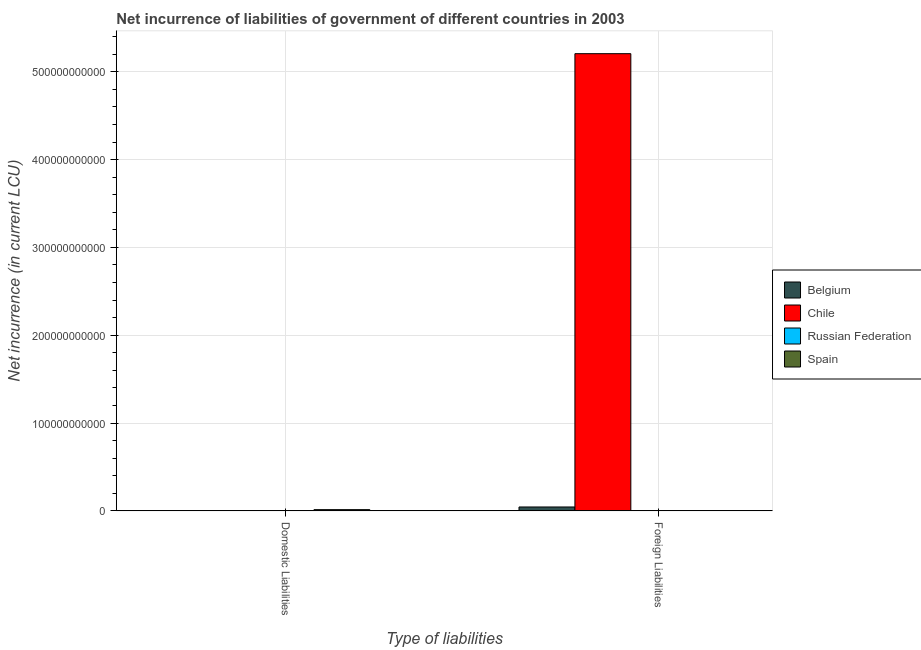How many different coloured bars are there?
Ensure brevity in your answer.  3. Are the number of bars on each tick of the X-axis equal?
Provide a succinct answer. No. How many bars are there on the 2nd tick from the left?
Give a very brief answer. 2. How many bars are there on the 2nd tick from the right?
Provide a short and direct response. 1. What is the label of the 1st group of bars from the left?
Keep it short and to the point. Domestic Liabilities. What is the net incurrence of foreign liabilities in Chile?
Make the answer very short. 5.21e+11. Across all countries, what is the maximum net incurrence of domestic liabilities?
Offer a terse response. 1.42e+09. What is the total net incurrence of foreign liabilities in the graph?
Your answer should be very brief. 5.25e+11. What is the difference between the net incurrence of foreign liabilities in Belgium and that in Chile?
Ensure brevity in your answer.  -5.16e+11. What is the difference between the net incurrence of foreign liabilities in Chile and the net incurrence of domestic liabilities in Belgium?
Your answer should be compact. 5.21e+11. What is the average net incurrence of domestic liabilities per country?
Your answer should be compact. 3.55e+08. In how many countries, is the net incurrence of domestic liabilities greater than the average net incurrence of domestic liabilities taken over all countries?
Offer a very short reply. 1. What is the difference between two consecutive major ticks on the Y-axis?
Give a very brief answer. 1.00e+11. Does the graph contain any zero values?
Offer a very short reply. Yes. What is the title of the graph?
Offer a terse response. Net incurrence of liabilities of government of different countries in 2003. Does "Mongolia" appear as one of the legend labels in the graph?
Your response must be concise. No. What is the label or title of the X-axis?
Offer a terse response. Type of liabilities. What is the label or title of the Y-axis?
Offer a very short reply. Net incurrence (in current LCU). What is the Net incurrence (in current LCU) in Belgium in Domestic Liabilities?
Your answer should be very brief. 0. What is the Net incurrence (in current LCU) in Spain in Domestic Liabilities?
Your answer should be very brief. 1.42e+09. What is the Net incurrence (in current LCU) of Belgium in Foreign Liabilities?
Keep it short and to the point. 4.45e+09. What is the Net incurrence (in current LCU) in Chile in Foreign Liabilities?
Ensure brevity in your answer.  5.21e+11. What is the Net incurrence (in current LCU) of Spain in Foreign Liabilities?
Offer a terse response. 0. Across all Type of liabilities, what is the maximum Net incurrence (in current LCU) of Belgium?
Offer a terse response. 4.45e+09. Across all Type of liabilities, what is the maximum Net incurrence (in current LCU) of Chile?
Keep it short and to the point. 5.21e+11. Across all Type of liabilities, what is the maximum Net incurrence (in current LCU) in Spain?
Make the answer very short. 1.42e+09. Across all Type of liabilities, what is the minimum Net incurrence (in current LCU) of Belgium?
Your answer should be compact. 0. Across all Type of liabilities, what is the minimum Net incurrence (in current LCU) of Chile?
Your response must be concise. 0. What is the total Net incurrence (in current LCU) in Belgium in the graph?
Make the answer very short. 4.45e+09. What is the total Net incurrence (in current LCU) in Chile in the graph?
Provide a succinct answer. 5.21e+11. What is the total Net incurrence (in current LCU) of Russian Federation in the graph?
Offer a very short reply. 0. What is the total Net incurrence (in current LCU) of Spain in the graph?
Your answer should be compact. 1.42e+09. What is the average Net incurrence (in current LCU) in Belgium per Type of liabilities?
Offer a very short reply. 2.23e+09. What is the average Net incurrence (in current LCU) in Chile per Type of liabilities?
Ensure brevity in your answer.  2.60e+11. What is the average Net incurrence (in current LCU) in Spain per Type of liabilities?
Ensure brevity in your answer.  7.10e+08. What is the difference between the Net incurrence (in current LCU) of Belgium and Net incurrence (in current LCU) of Chile in Foreign Liabilities?
Provide a succinct answer. -5.16e+11. What is the difference between the highest and the lowest Net incurrence (in current LCU) in Belgium?
Offer a terse response. 4.45e+09. What is the difference between the highest and the lowest Net incurrence (in current LCU) of Chile?
Your answer should be very brief. 5.21e+11. What is the difference between the highest and the lowest Net incurrence (in current LCU) in Spain?
Offer a very short reply. 1.42e+09. 